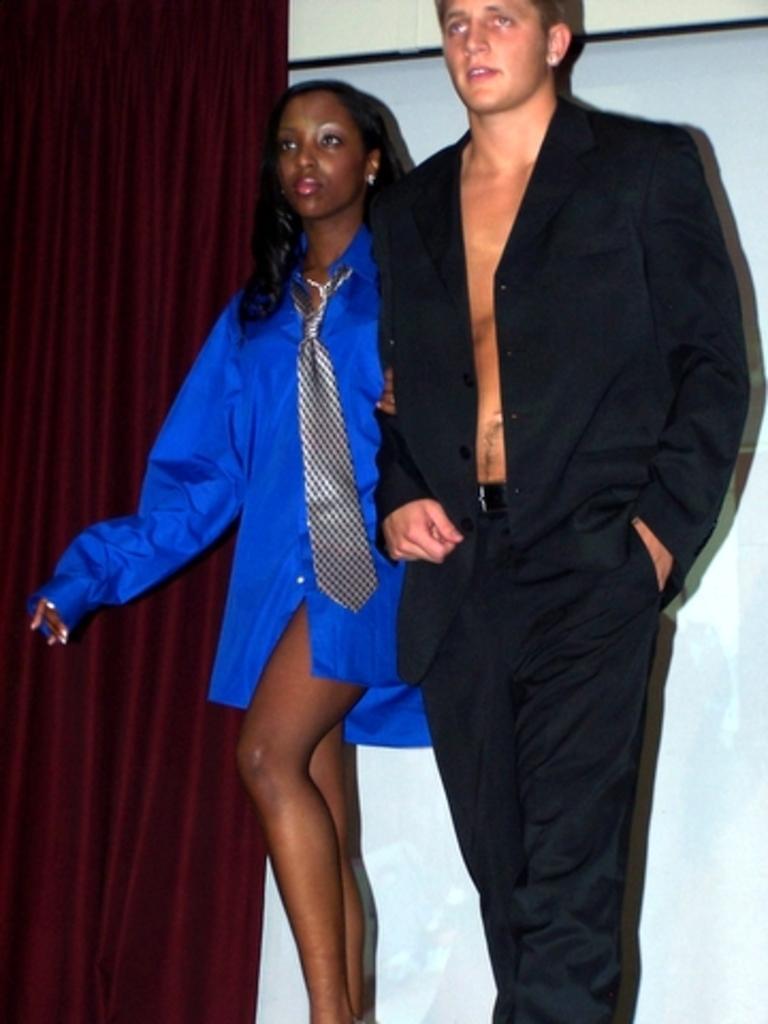In one or two sentences, can you explain what this image depicts? In the image we can see there are people standing and the woman is wearing tie. Behind there is a curtain. 